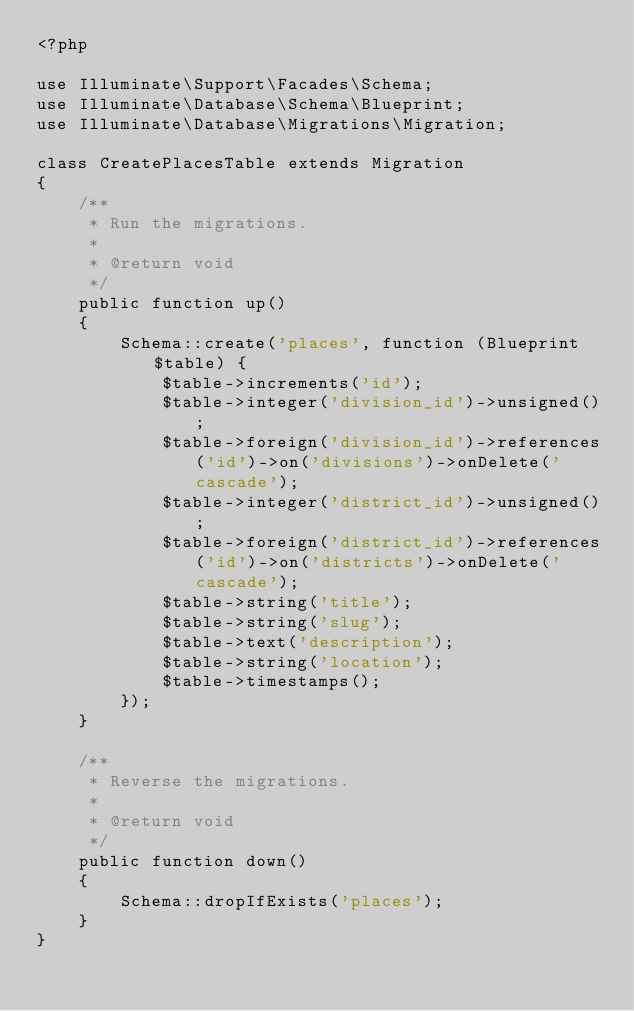<code> <loc_0><loc_0><loc_500><loc_500><_PHP_><?php

use Illuminate\Support\Facades\Schema;
use Illuminate\Database\Schema\Blueprint;
use Illuminate\Database\Migrations\Migration;

class CreatePlacesTable extends Migration
{
    /**
     * Run the migrations.
     *
     * @return void
     */
    public function up()
    {
        Schema::create('places', function (Blueprint $table) {
            $table->increments('id');
            $table->integer('division_id')->unsigned();
            $table->foreign('division_id')->references('id')->on('divisions')->onDelete('cascade');
            $table->integer('district_id')->unsigned();
            $table->foreign('district_id')->references('id')->on('districts')->onDelete('cascade');
            $table->string('title');
            $table->string('slug');
            $table->text('description');
            $table->string('location');
            $table->timestamps();
        });
    }

    /**
     * Reverse the migrations.
     *
     * @return void
     */
    public function down()
    {
        Schema::dropIfExists('places');
    }
}
</code> 